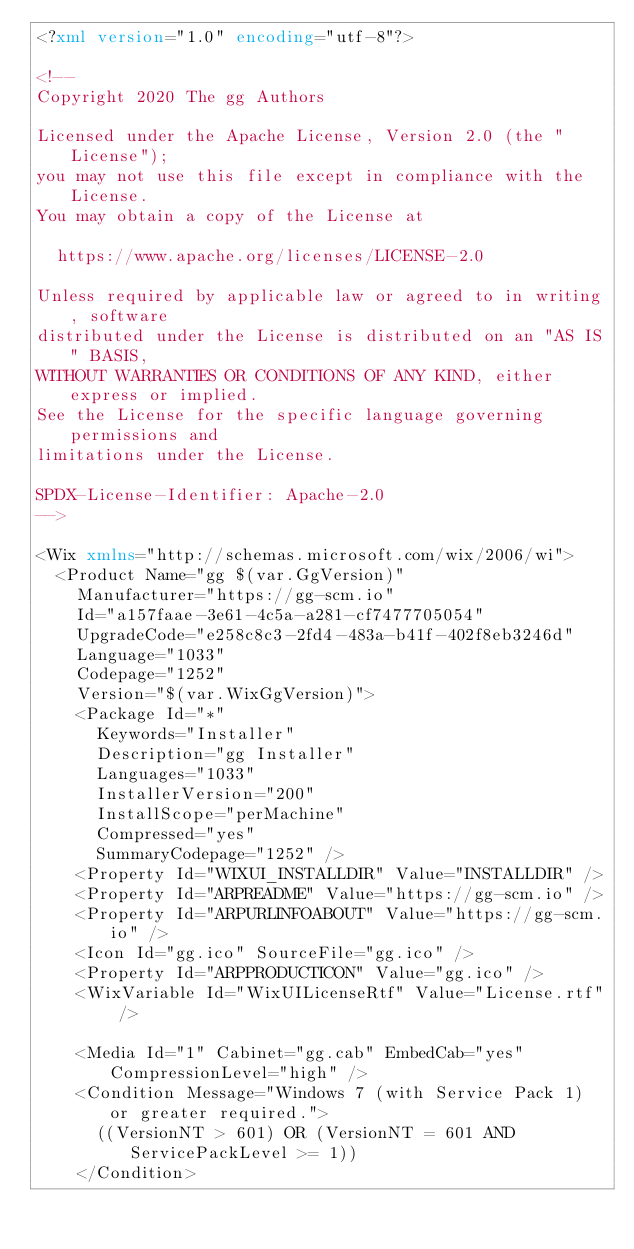<code> <loc_0><loc_0><loc_500><loc_500><_XML_><?xml version="1.0" encoding="utf-8"?>

<!--
Copyright 2020 The gg Authors

Licensed under the Apache License, Version 2.0 (the "License");
you may not use this file except in compliance with the License.
You may obtain a copy of the License at

  https://www.apache.org/licenses/LICENSE-2.0

Unless required by applicable law or agreed to in writing, software
distributed under the License is distributed on an "AS IS" BASIS,
WITHOUT WARRANTIES OR CONDITIONS OF ANY KIND, either express or implied.
See the License for the specific language governing permissions and
limitations under the License.

SPDX-License-Identifier: Apache-2.0
-->

<Wix xmlns="http://schemas.microsoft.com/wix/2006/wi">
  <Product Name="gg $(var.GgVersion)"
    Manufacturer="https://gg-scm.io"
    Id="a157faae-3e61-4c5a-a281-cf7477705054"
    UpgradeCode="e258c8c3-2fd4-483a-b41f-402f8eb3246d"
    Language="1033"
    Codepage="1252"
    Version="$(var.WixGgVersion)">
    <Package Id="*"
      Keywords="Installer"
      Description="gg Installer"
      Languages="1033"
      InstallerVersion="200"
      InstallScope="perMachine"
      Compressed="yes"
      SummaryCodepage="1252" />
    <Property Id="WIXUI_INSTALLDIR" Value="INSTALLDIR" />
    <Property Id="ARPREADME" Value="https://gg-scm.io" />
    <Property Id="ARPURLINFOABOUT" Value="https://gg-scm.io" />
    <Icon Id="gg.ico" SourceFile="gg.ico" />
    <Property Id="ARPPRODUCTICON" Value="gg.ico" />
    <WixVariable Id="WixUILicenseRtf" Value="License.rtf" />

    <Media Id="1" Cabinet="gg.cab" EmbedCab="yes" CompressionLevel="high" />
    <Condition Message="Windows 7 (with Service Pack 1) or greater required.">
      ((VersionNT > 601) OR (VersionNT = 601 AND ServicePackLevel >= 1))
    </Condition>
</code> 